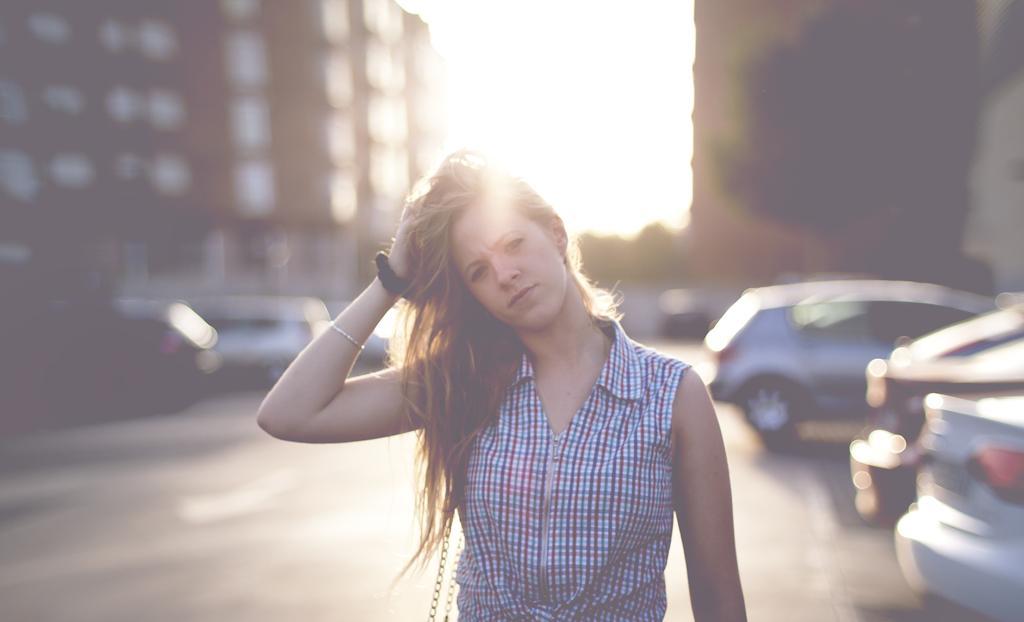Describe this image in one or two sentences. In this image I can see the person standing and the person is wearing white, red and blue color shirt. In the background I can see few vehicles, buildings in the sky is in white color. 